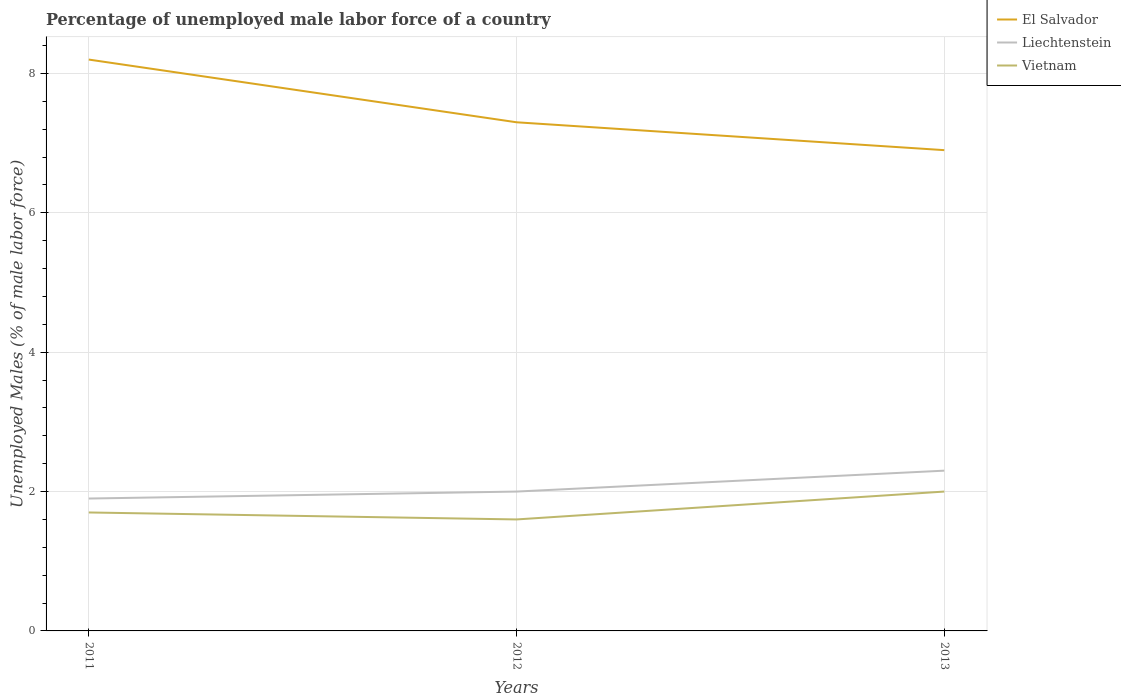How many different coloured lines are there?
Your answer should be very brief. 3. Does the line corresponding to El Salvador intersect with the line corresponding to Vietnam?
Give a very brief answer. No. Is the number of lines equal to the number of legend labels?
Your response must be concise. Yes. Across all years, what is the maximum percentage of unemployed male labor force in Vietnam?
Make the answer very short. 1.6. What is the total percentage of unemployed male labor force in Vietnam in the graph?
Ensure brevity in your answer.  -0.3. What is the difference between the highest and the second highest percentage of unemployed male labor force in El Salvador?
Offer a terse response. 1.3. What is the difference between the highest and the lowest percentage of unemployed male labor force in El Salvador?
Make the answer very short. 1. How many years are there in the graph?
Keep it short and to the point. 3. What is the difference between two consecutive major ticks on the Y-axis?
Provide a succinct answer. 2. Are the values on the major ticks of Y-axis written in scientific E-notation?
Give a very brief answer. No. Does the graph contain any zero values?
Offer a very short reply. No. Does the graph contain grids?
Offer a very short reply. Yes. How are the legend labels stacked?
Give a very brief answer. Vertical. What is the title of the graph?
Your answer should be compact. Percentage of unemployed male labor force of a country. What is the label or title of the X-axis?
Your answer should be compact. Years. What is the label or title of the Y-axis?
Provide a succinct answer. Unemployed Males (% of male labor force). What is the Unemployed Males (% of male labor force) of El Salvador in 2011?
Provide a succinct answer. 8.2. What is the Unemployed Males (% of male labor force) of Liechtenstein in 2011?
Keep it short and to the point. 1.9. What is the Unemployed Males (% of male labor force) of Vietnam in 2011?
Ensure brevity in your answer.  1.7. What is the Unemployed Males (% of male labor force) in El Salvador in 2012?
Keep it short and to the point. 7.3. What is the Unemployed Males (% of male labor force) of Vietnam in 2012?
Offer a very short reply. 1.6. What is the Unemployed Males (% of male labor force) of El Salvador in 2013?
Ensure brevity in your answer.  6.9. What is the Unemployed Males (% of male labor force) of Liechtenstein in 2013?
Make the answer very short. 2.3. Across all years, what is the maximum Unemployed Males (% of male labor force) in El Salvador?
Your answer should be compact. 8.2. Across all years, what is the maximum Unemployed Males (% of male labor force) in Liechtenstein?
Provide a short and direct response. 2.3. Across all years, what is the minimum Unemployed Males (% of male labor force) in El Salvador?
Your answer should be very brief. 6.9. Across all years, what is the minimum Unemployed Males (% of male labor force) in Liechtenstein?
Ensure brevity in your answer.  1.9. Across all years, what is the minimum Unemployed Males (% of male labor force) of Vietnam?
Offer a very short reply. 1.6. What is the total Unemployed Males (% of male labor force) in El Salvador in the graph?
Keep it short and to the point. 22.4. What is the difference between the Unemployed Males (% of male labor force) in Liechtenstein in 2011 and that in 2012?
Provide a short and direct response. -0.1. What is the difference between the Unemployed Males (% of male labor force) of Vietnam in 2011 and that in 2013?
Provide a short and direct response. -0.3. What is the difference between the Unemployed Males (% of male labor force) of Vietnam in 2012 and that in 2013?
Offer a terse response. -0.4. What is the difference between the Unemployed Males (% of male labor force) of El Salvador in 2011 and the Unemployed Males (% of male labor force) of Liechtenstein in 2012?
Make the answer very short. 6.2. What is the difference between the Unemployed Males (% of male labor force) of El Salvador in 2011 and the Unemployed Males (% of male labor force) of Vietnam in 2012?
Provide a succinct answer. 6.6. What is the difference between the Unemployed Males (% of male labor force) of El Salvador in 2012 and the Unemployed Males (% of male labor force) of Liechtenstein in 2013?
Provide a short and direct response. 5. What is the difference between the Unemployed Males (% of male labor force) of El Salvador in 2012 and the Unemployed Males (% of male labor force) of Vietnam in 2013?
Make the answer very short. 5.3. What is the average Unemployed Males (% of male labor force) in El Salvador per year?
Ensure brevity in your answer.  7.47. What is the average Unemployed Males (% of male labor force) of Liechtenstein per year?
Offer a terse response. 2.07. What is the average Unemployed Males (% of male labor force) of Vietnam per year?
Provide a succinct answer. 1.77. In the year 2011, what is the difference between the Unemployed Males (% of male labor force) of El Salvador and Unemployed Males (% of male labor force) of Liechtenstein?
Give a very brief answer. 6.3. In the year 2012, what is the difference between the Unemployed Males (% of male labor force) of El Salvador and Unemployed Males (% of male labor force) of Vietnam?
Your answer should be very brief. 5.7. What is the ratio of the Unemployed Males (% of male labor force) of El Salvador in 2011 to that in 2012?
Keep it short and to the point. 1.12. What is the ratio of the Unemployed Males (% of male labor force) in El Salvador in 2011 to that in 2013?
Offer a very short reply. 1.19. What is the ratio of the Unemployed Males (% of male labor force) in Liechtenstein in 2011 to that in 2013?
Your answer should be compact. 0.83. What is the ratio of the Unemployed Males (% of male labor force) of Vietnam in 2011 to that in 2013?
Make the answer very short. 0.85. What is the ratio of the Unemployed Males (% of male labor force) in El Salvador in 2012 to that in 2013?
Your answer should be very brief. 1.06. What is the ratio of the Unemployed Males (% of male labor force) in Liechtenstein in 2012 to that in 2013?
Offer a terse response. 0.87. What is the difference between the highest and the lowest Unemployed Males (% of male labor force) of El Salvador?
Give a very brief answer. 1.3. What is the difference between the highest and the lowest Unemployed Males (% of male labor force) of Liechtenstein?
Your response must be concise. 0.4. What is the difference between the highest and the lowest Unemployed Males (% of male labor force) of Vietnam?
Offer a very short reply. 0.4. 